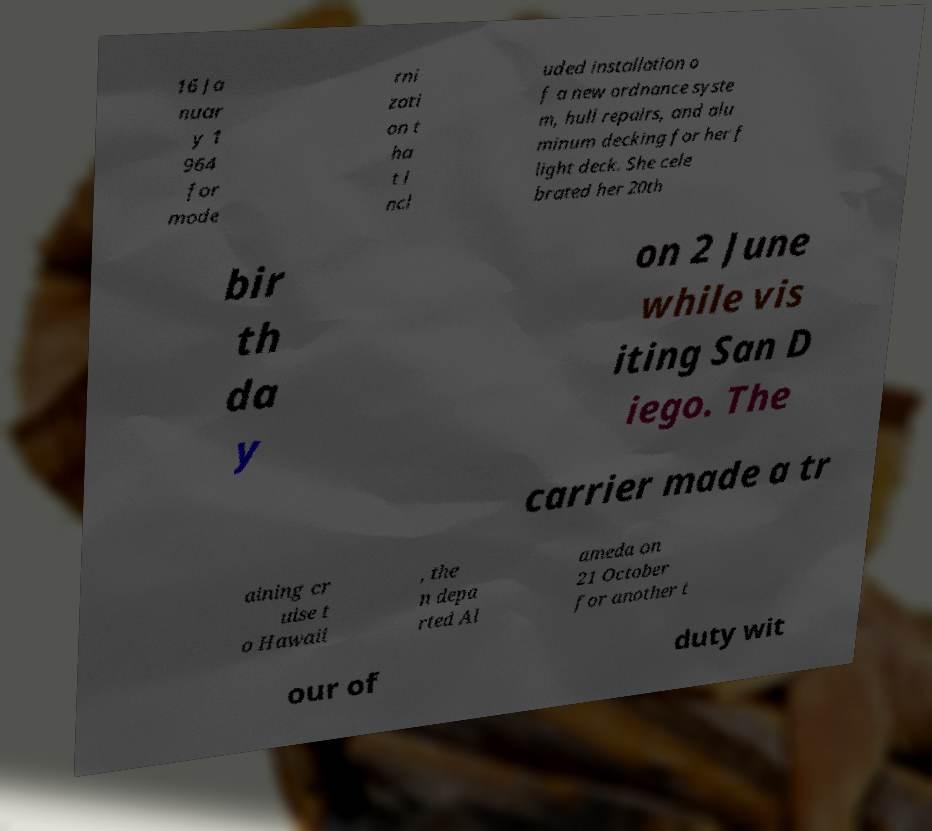There's text embedded in this image that I need extracted. Can you transcribe it verbatim? 16 Ja nuar y 1 964 for mode rni zati on t ha t i ncl uded installation o f a new ordnance syste m, hull repairs, and alu minum decking for her f light deck. She cele brated her 20th bir th da y on 2 June while vis iting San D iego. The carrier made a tr aining cr uise t o Hawaii , the n depa rted Al ameda on 21 October for another t our of duty wit 